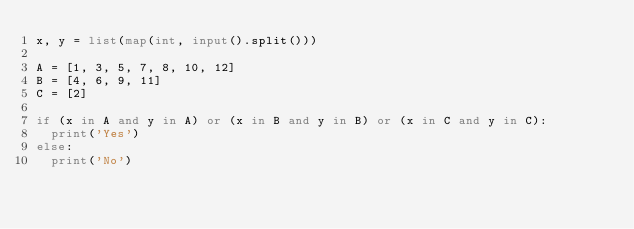<code> <loc_0><loc_0><loc_500><loc_500><_Python_>x, y = list(map(int, input().split()))

A = [1, 3, 5, 7, 8, 10, 12]
B = [4, 6, 9, 11]
C = [2]

if (x in A and y in A) or (x in B and y in B) or (x in C and y in C):
	print('Yes')	
else:
	print('No')</code> 